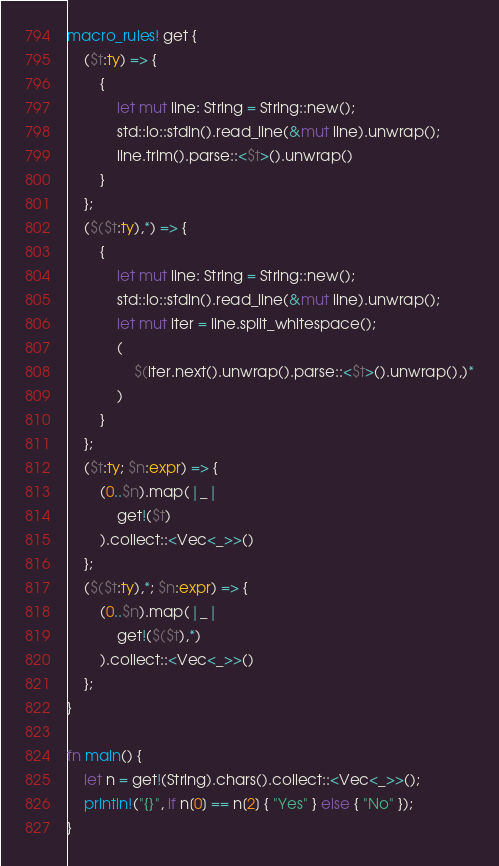<code> <loc_0><loc_0><loc_500><loc_500><_Rust_>macro_rules! get {
    ($t:ty) => {
        {
            let mut line: String = String::new();
            std::io::stdin().read_line(&mut line).unwrap();
            line.trim().parse::<$t>().unwrap()
        }
    };
    ($($t:ty),*) => {
        {
            let mut line: String = String::new();
            std::io::stdin().read_line(&mut line).unwrap();
            let mut iter = line.split_whitespace();
            (
                $(iter.next().unwrap().parse::<$t>().unwrap(),)*
            )
        }
    };
    ($t:ty; $n:expr) => {
        (0..$n).map(|_|
            get!($t)
        ).collect::<Vec<_>>()
    };
    ($($t:ty),*; $n:expr) => {
        (0..$n).map(|_|
            get!($($t),*)
        ).collect::<Vec<_>>()
    };
}

fn main() {
    let n = get!(String).chars().collect::<Vec<_>>();
    println!("{}", if n[0] == n[2] { "Yes" } else { "No" });
}</code> 